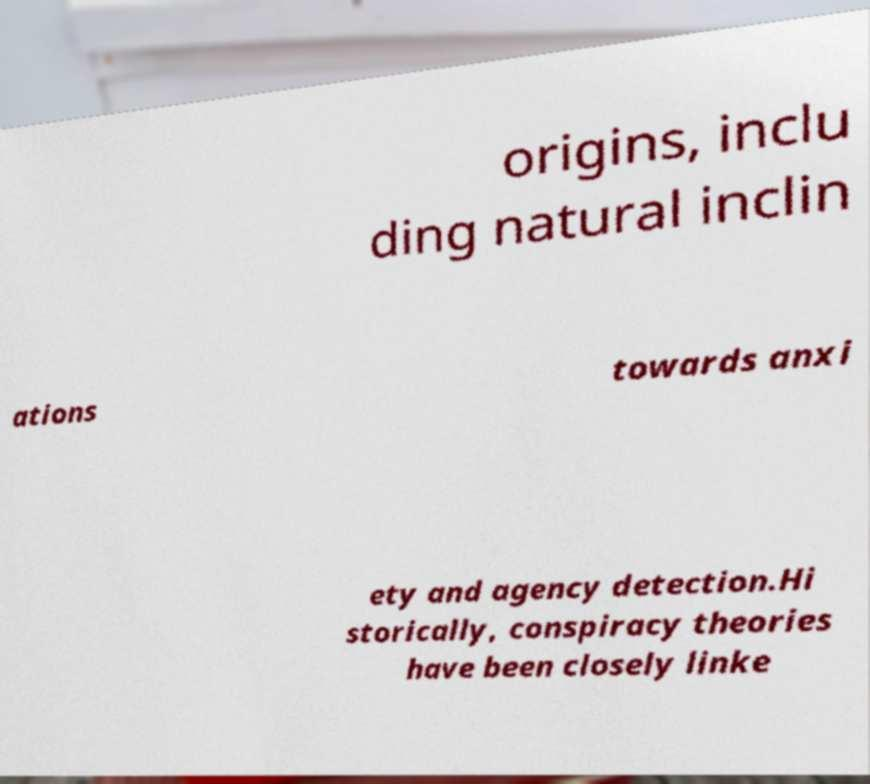There's text embedded in this image that I need extracted. Can you transcribe it verbatim? origins, inclu ding natural inclin ations towards anxi ety and agency detection.Hi storically, conspiracy theories have been closely linke 